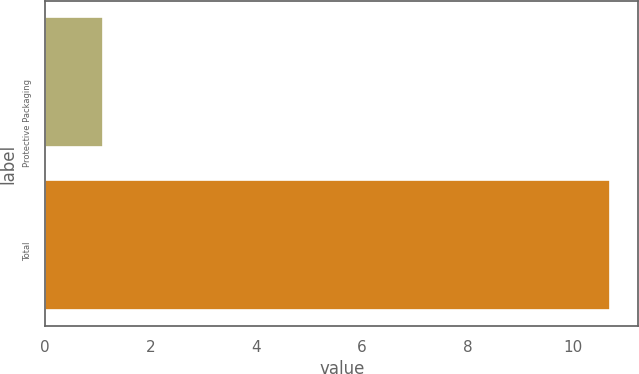Convert chart. <chart><loc_0><loc_0><loc_500><loc_500><bar_chart><fcel>Protective Packaging<fcel>Total<nl><fcel>1.1<fcel>10.7<nl></chart> 